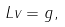<formula> <loc_0><loc_0><loc_500><loc_500>L v = g ,</formula> 